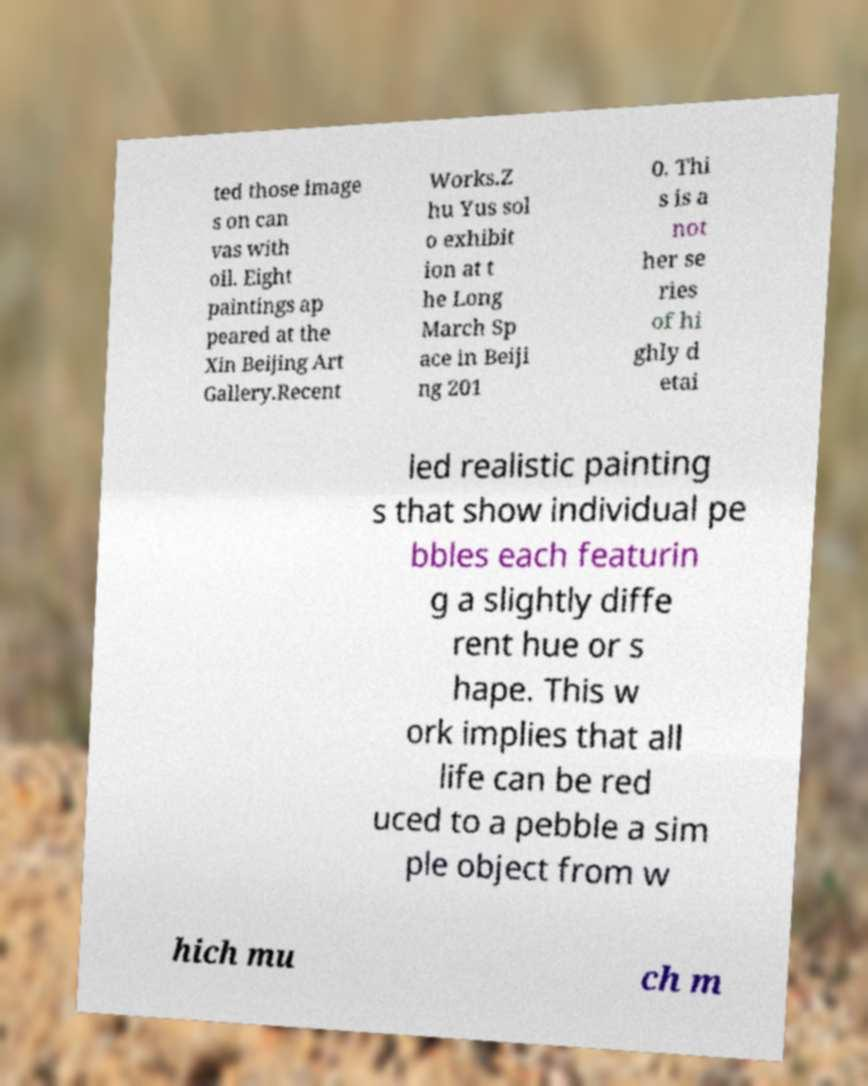Can you read and provide the text displayed in the image?This photo seems to have some interesting text. Can you extract and type it out for me? ted those image s on can vas with oil. Eight paintings ap peared at the Xin Beijing Art Gallery.Recent Works.Z hu Yus sol o exhibit ion at t he Long March Sp ace in Beiji ng 201 0. Thi s is a not her se ries of hi ghly d etai led realistic painting s that show individual pe bbles each featurin g a slightly diffe rent hue or s hape. This w ork implies that all life can be red uced to a pebble a sim ple object from w hich mu ch m 